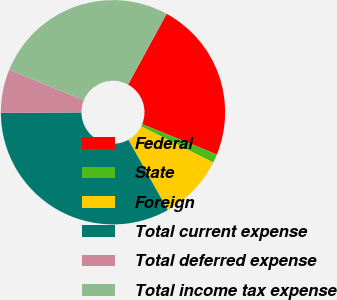Convert chart. <chart><loc_0><loc_0><loc_500><loc_500><pie_chart><fcel>Federal<fcel>State<fcel>Foreign<fcel>Total current expense<fcel>Total deferred expense<fcel>Total income tax expense<nl><fcel>23.21%<fcel>1.25%<fcel>9.47%<fcel>33.03%<fcel>6.29%<fcel>26.74%<nl></chart> 